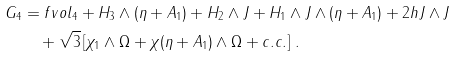Convert formula to latex. <formula><loc_0><loc_0><loc_500><loc_500>G _ { 4 } & = f v o l _ { 4 } + H _ { 3 } \wedge ( \eta + A _ { 1 } ) + H _ { 2 } \wedge J + H _ { 1 } \wedge J \wedge ( \eta + A _ { 1 } ) + 2 h J \wedge J \\ & \quad + { \sqrt { 3 } } \left [ \chi _ { 1 } \wedge \Omega + \chi ( \eta + A _ { 1 } ) \wedge \Omega + c . c . \right ] \, .</formula> 